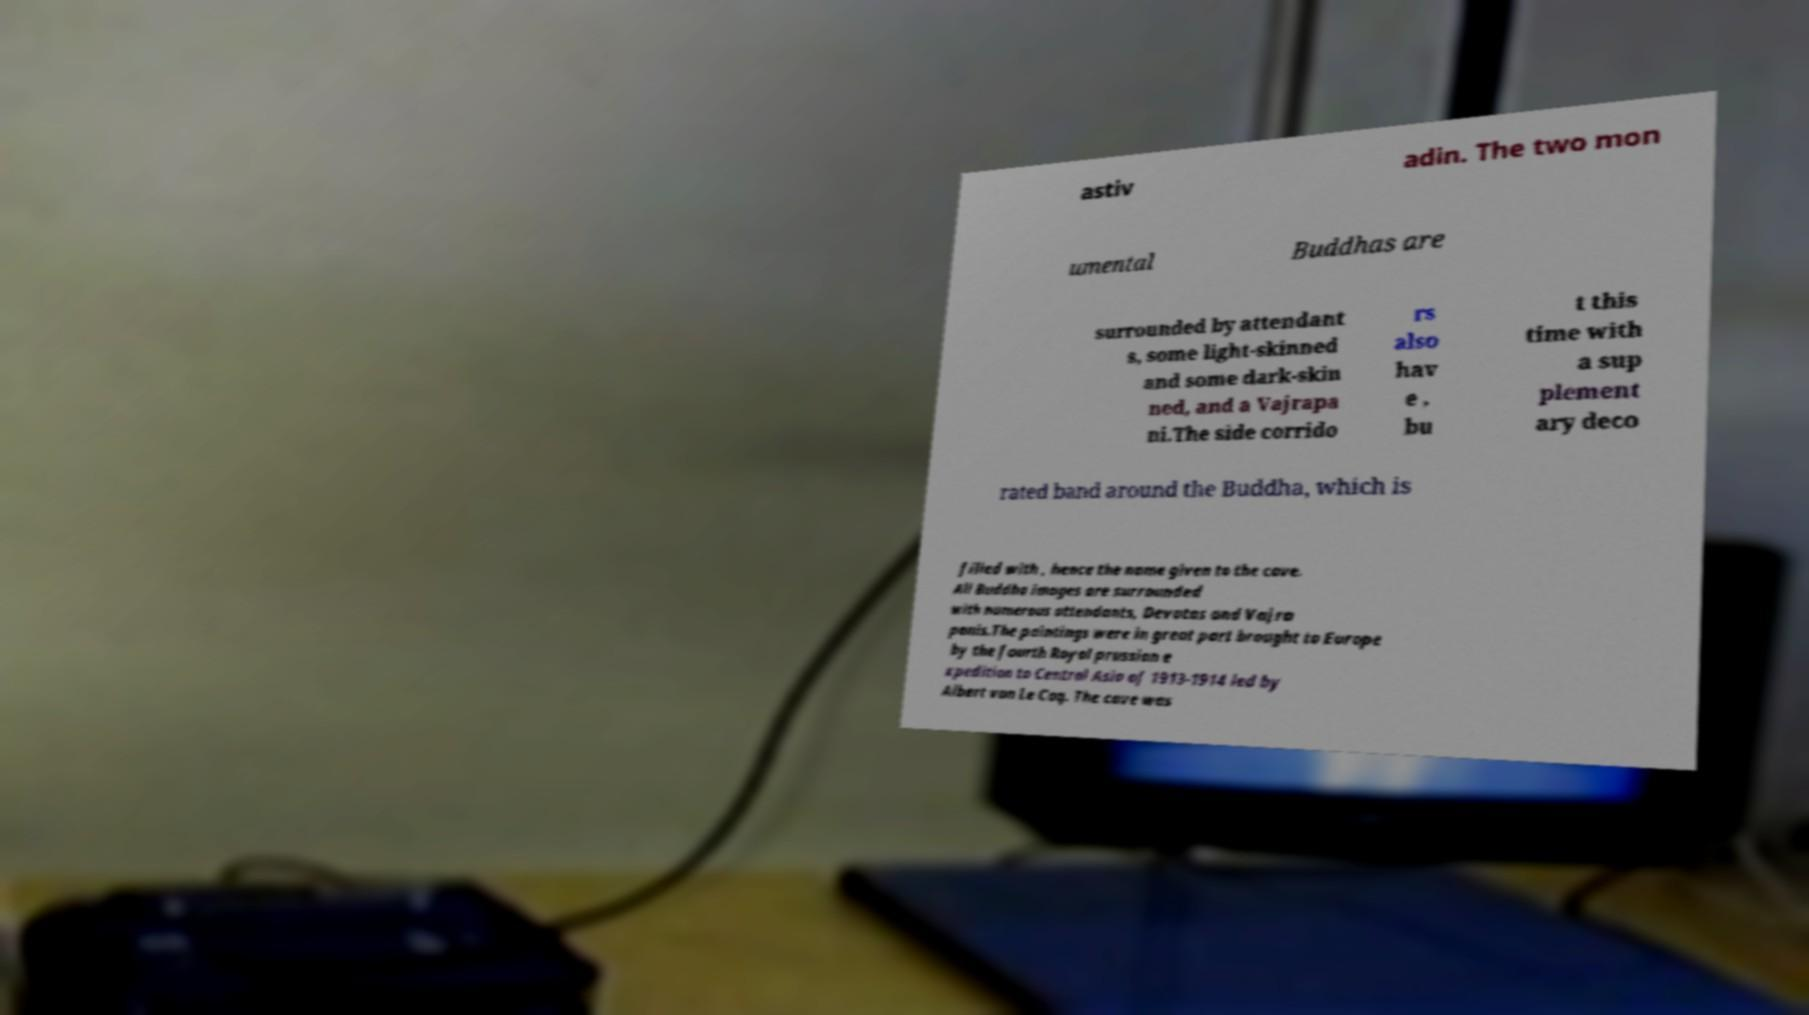What messages or text are displayed in this image? I need them in a readable, typed format. astiv adin. The two mon umental Buddhas are surrounded by attendant s, some light-skinned and some dark-skin ned, and a Vajrapa ni.The side corrido rs also hav e , bu t this time with a sup plement ary deco rated band around the Buddha, which is filled with , hence the name given to the cave. All Buddha images are surrounded with numerous attendants, Devatas and Vajra panis.The paintings were in great part brought to Europe by the fourth Royal prussian e xpedition to Central Asia of 1913-1914 led by Albert von Le Coq. The cave was 